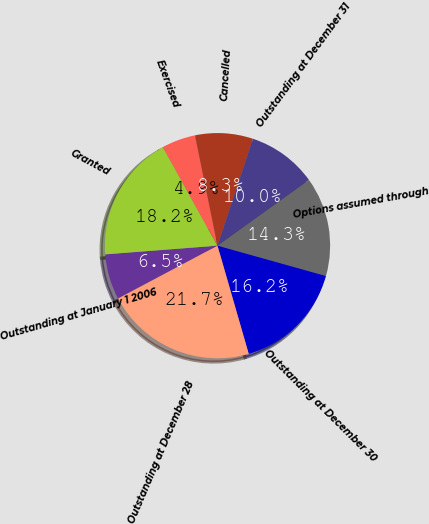<chart> <loc_0><loc_0><loc_500><loc_500><pie_chart><fcel>Outstanding at January 1 2006<fcel>Granted<fcel>Exercised<fcel>Cancelled<fcel>Outstanding at December 31<fcel>Options assumed through<fcel>Outstanding at December 30<fcel>Outstanding at December 28<nl><fcel>6.54%<fcel>18.17%<fcel>4.86%<fcel>8.3%<fcel>9.98%<fcel>14.26%<fcel>16.19%<fcel>21.7%<nl></chart> 